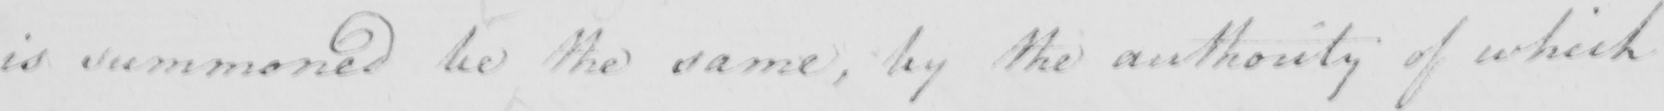What is written in this line of handwriting? is summoned be the same , by the authority of which 